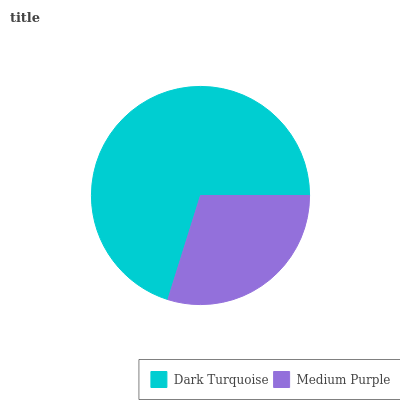Is Medium Purple the minimum?
Answer yes or no. Yes. Is Dark Turquoise the maximum?
Answer yes or no. Yes. Is Medium Purple the maximum?
Answer yes or no. No. Is Dark Turquoise greater than Medium Purple?
Answer yes or no. Yes. Is Medium Purple less than Dark Turquoise?
Answer yes or no. Yes. Is Medium Purple greater than Dark Turquoise?
Answer yes or no. No. Is Dark Turquoise less than Medium Purple?
Answer yes or no. No. Is Dark Turquoise the high median?
Answer yes or no. Yes. Is Medium Purple the low median?
Answer yes or no. Yes. Is Medium Purple the high median?
Answer yes or no. No. Is Dark Turquoise the low median?
Answer yes or no. No. 